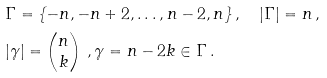<formula> <loc_0><loc_0><loc_500><loc_500>& \Gamma = \{ - n , - n + 2 , \dots , n - 2 , n \} \, , \quad | \Gamma | = n \, , \\ & | \gamma | = \begin{pmatrix} n \\ k \end{pmatrix} \, , \gamma = n - 2 k \in \Gamma \, .</formula> 